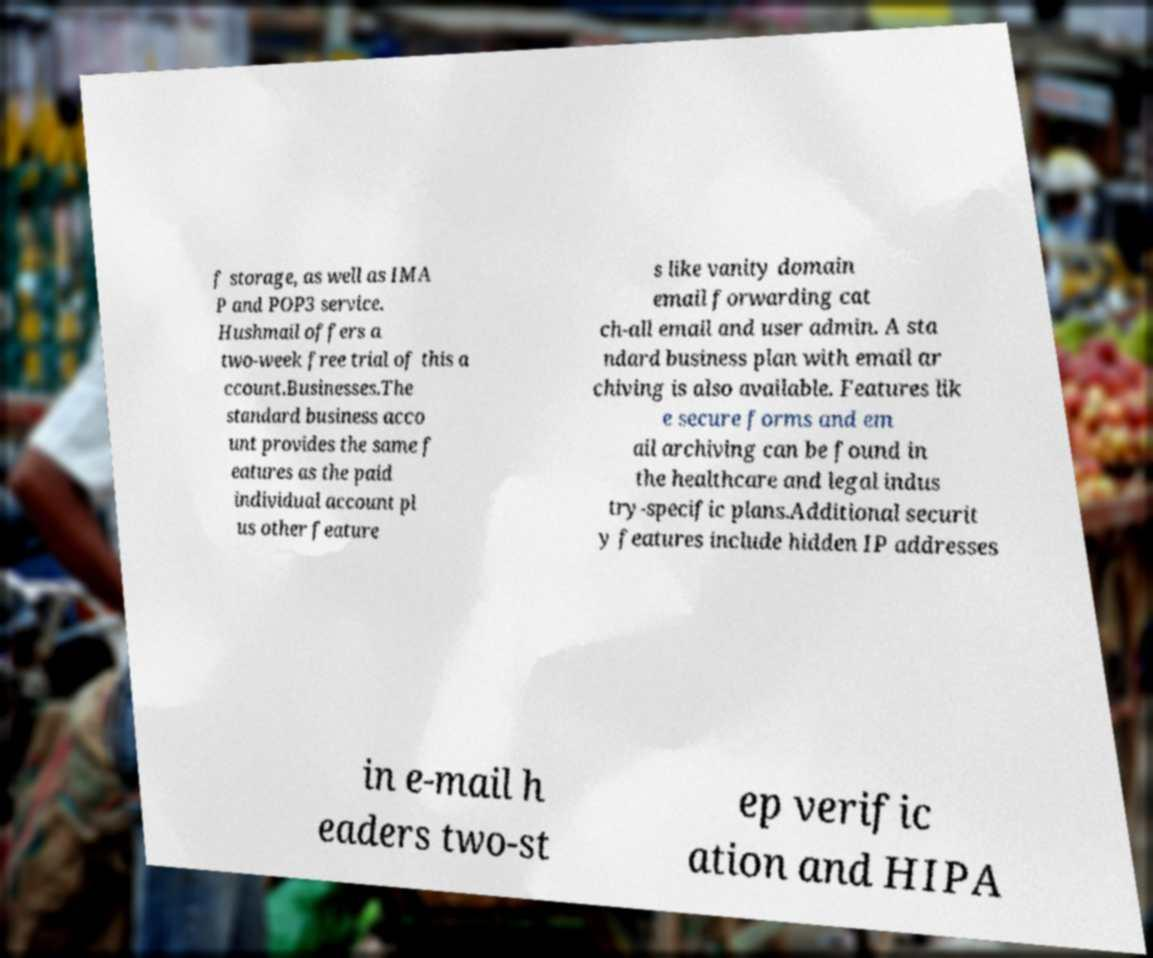What messages or text are displayed in this image? I need them in a readable, typed format. f storage, as well as IMA P and POP3 service. Hushmail offers a two-week free trial of this a ccount.Businesses.The standard business acco unt provides the same f eatures as the paid individual account pl us other feature s like vanity domain email forwarding cat ch-all email and user admin. A sta ndard business plan with email ar chiving is also available. Features lik e secure forms and em ail archiving can be found in the healthcare and legal indus try-specific plans.Additional securit y features include hidden IP addresses in e-mail h eaders two-st ep verific ation and HIPA 